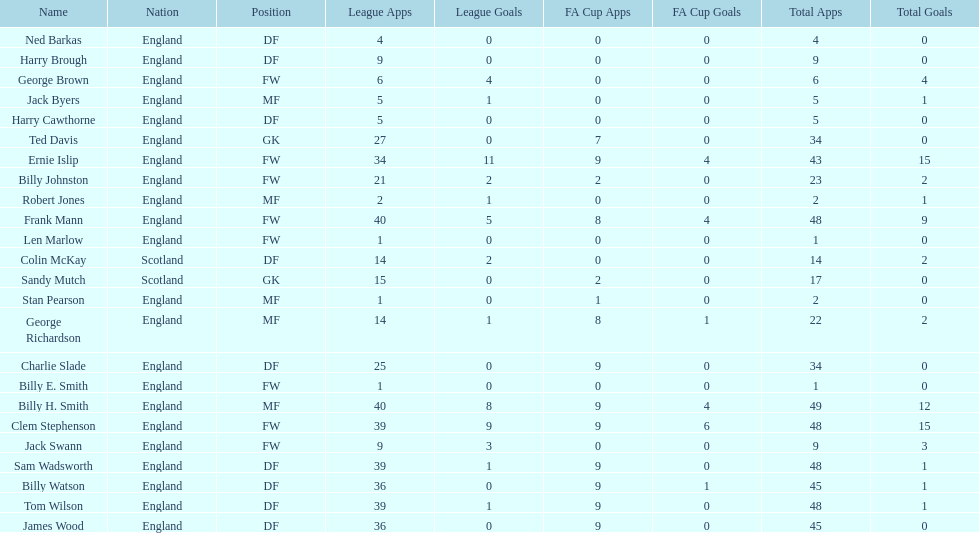Name the nation with the most appearances. England. Help me parse the entirety of this table. {'header': ['Name', 'Nation', 'Position', 'League Apps', 'League Goals', 'FA Cup Apps', 'FA Cup Goals', 'Total Apps', 'Total Goals'], 'rows': [['Ned Barkas', 'England', 'DF', '4', '0', '0', '0', '4', '0'], ['Harry Brough', 'England', 'DF', '9', '0', '0', '0', '9', '0'], ['George Brown', 'England', 'FW', '6', '4', '0', '0', '6', '4'], ['Jack Byers', 'England', 'MF', '5', '1', '0', '0', '5', '1'], ['Harry Cawthorne', 'England', 'DF', '5', '0', '0', '0', '5', '0'], ['Ted Davis', 'England', 'GK', '27', '0', '7', '0', '34', '0'], ['Ernie Islip', 'England', 'FW', '34', '11', '9', '4', '43', '15'], ['Billy Johnston', 'England', 'FW', '21', '2', '2', '0', '23', '2'], ['Robert Jones', 'England', 'MF', '2', '1', '0', '0', '2', '1'], ['Frank Mann', 'England', 'FW', '40', '5', '8', '4', '48', '9'], ['Len Marlow', 'England', 'FW', '1', '0', '0', '0', '1', '0'], ['Colin McKay', 'Scotland', 'DF', '14', '2', '0', '0', '14', '2'], ['Sandy Mutch', 'Scotland', 'GK', '15', '0', '2', '0', '17', '0'], ['Stan Pearson', 'England', 'MF', '1', '0', '1', '0', '2', '0'], ['George Richardson', 'England', 'MF', '14', '1', '8', '1', '22', '2'], ['Charlie Slade', 'England', 'DF', '25', '0', '9', '0', '34', '0'], ['Billy E. Smith', 'England', 'FW', '1', '0', '0', '0', '1', '0'], ['Billy H. Smith', 'England', 'MF', '40', '8', '9', '4', '49', '12'], ['Clem Stephenson', 'England', 'FW', '39', '9', '9', '6', '48', '15'], ['Jack Swann', 'England', 'FW', '9', '3', '0', '0', '9', '3'], ['Sam Wadsworth', 'England', 'DF', '39', '1', '9', '0', '48', '1'], ['Billy Watson', 'England', 'DF', '36', '0', '9', '1', '45', '1'], ['Tom Wilson', 'England', 'DF', '39', '1', '9', '0', '48', '1'], ['James Wood', 'England', 'DF', '36', '0', '9', '0', '45', '0']]} 